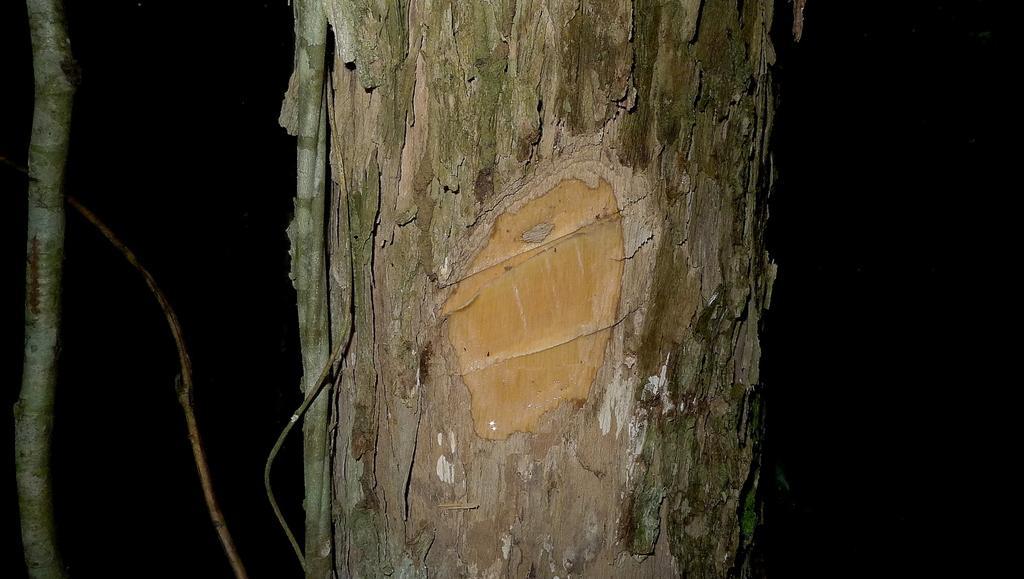Please provide a concise description of this image. In this image I can see a branch which is in brown and greenish color. I can see a black background. 